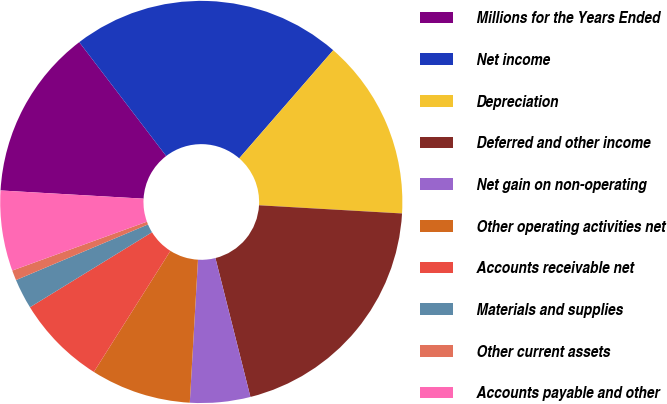Convert chart. <chart><loc_0><loc_0><loc_500><loc_500><pie_chart><fcel>Millions for the Years Ended<fcel>Net income<fcel>Depreciation<fcel>Deferred and other income<fcel>Net gain on non-operating<fcel>Other operating activities net<fcel>Accounts receivable net<fcel>Materials and supplies<fcel>Other current assets<fcel>Accounts payable and other<nl><fcel>13.71%<fcel>21.77%<fcel>14.52%<fcel>20.16%<fcel>4.84%<fcel>8.06%<fcel>7.26%<fcel>2.42%<fcel>0.81%<fcel>6.45%<nl></chart> 